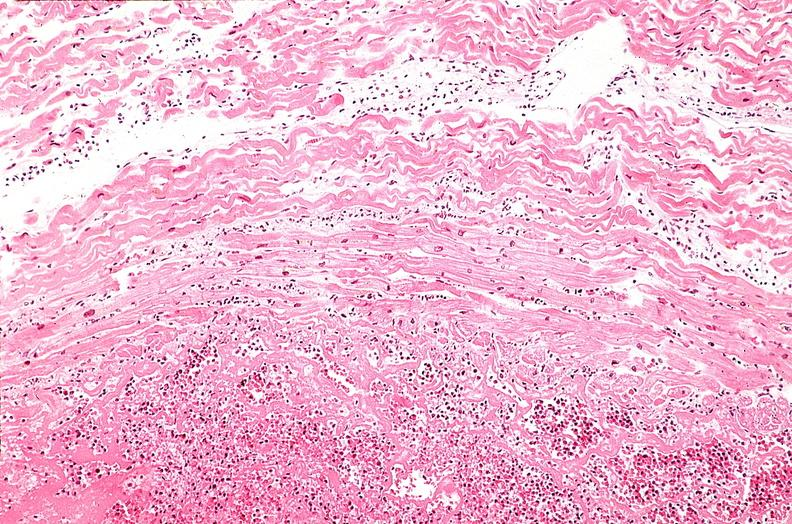what does this image show?
Answer the question using a single word or phrase. Heart 